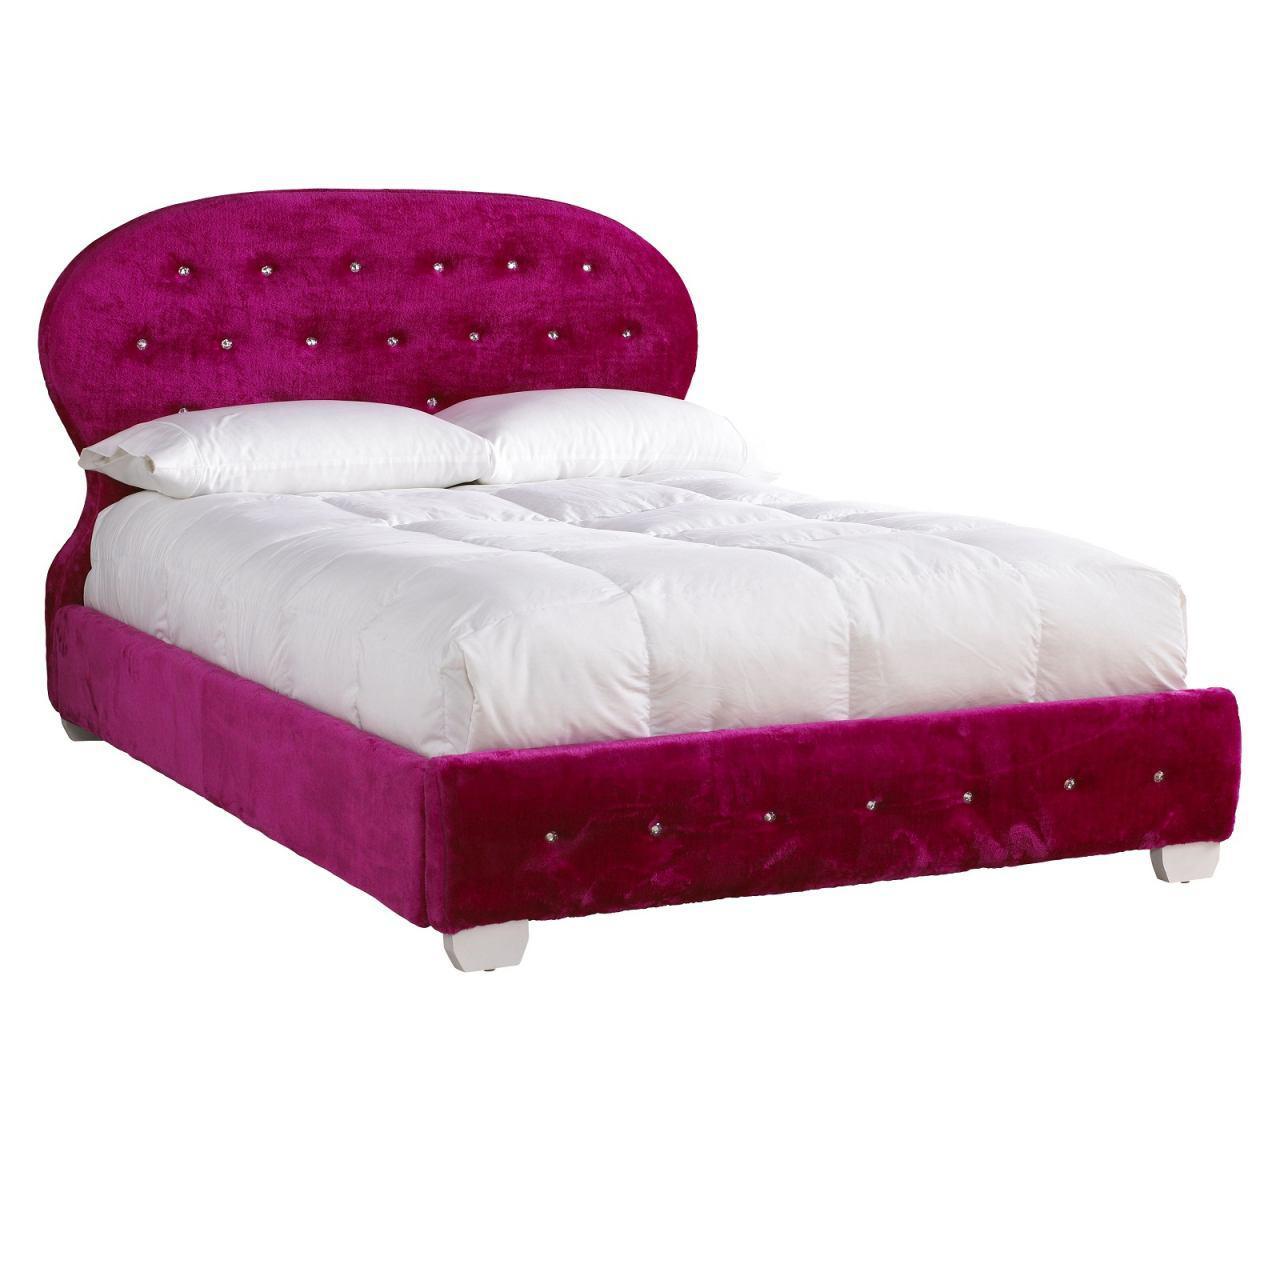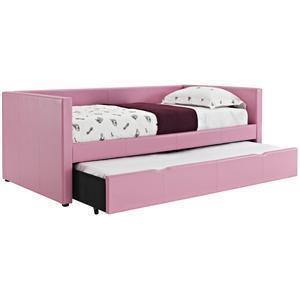The first image is the image on the left, the second image is the image on the right. Examine the images to the left and right. Is the description "There is a single pink bed with a pull out trundle bed attached underneath it" accurate? Answer yes or no. Yes. The first image is the image on the left, the second image is the image on the right. Considering the images on both sides, is "Both head- and foot-board of one bed are upholstered and tufted with purple fabric." valid? Answer yes or no. Yes. 